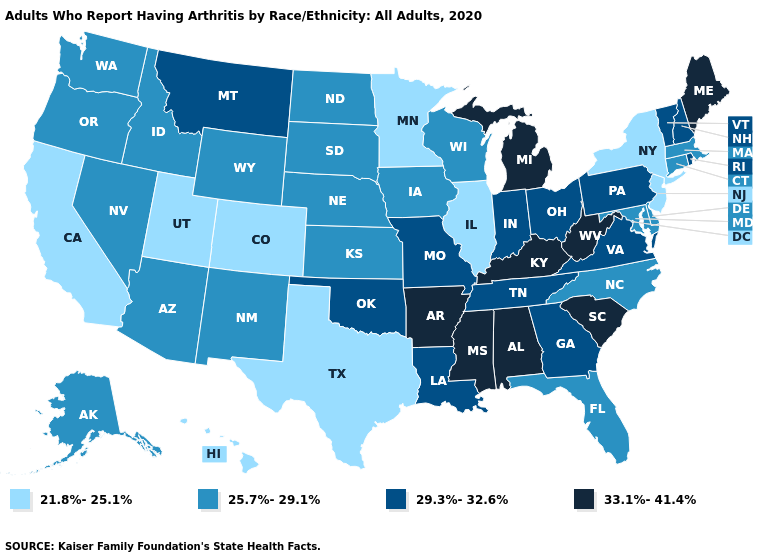Name the states that have a value in the range 33.1%-41.4%?
Concise answer only. Alabama, Arkansas, Kentucky, Maine, Michigan, Mississippi, South Carolina, West Virginia. Which states have the highest value in the USA?
Give a very brief answer. Alabama, Arkansas, Kentucky, Maine, Michigan, Mississippi, South Carolina, West Virginia. Name the states that have a value in the range 25.7%-29.1%?
Short answer required. Alaska, Arizona, Connecticut, Delaware, Florida, Idaho, Iowa, Kansas, Maryland, Massachusetts, Nebraska, Nevada, New Mexico, North Carolina, North Dakota, Oregon, South Dakota, Washington, Wisconsin, Wyoming. What is the highest value in the West ?
Answer briefly. 29.3%-32.6%. Does North Carolina have a higher value than Pennsylvania?
Concise answer only. No. Name the states that have a value in the range 21.8%-25.1%?
Concise answer only. California, Colorado, Hawaii, Illinois, Minnesota, New Jersey, New York, Texas, Utah. Name the states that have a value in the range 25.7%-29.1%?
Write a very short answer. Alaska, Arizona, Connecticut, Delaware, Florida, Idaho, Iowa, Kansas, Maryland, Massachusetts, Nebraska, Nevada, New Mexico, North Carolina, North Dakota, Oregon, South Dakota, Washington, Wisconsin, Wyoming. What is the value of Kansas?
Keep it brief. 25.7%-29.1%. Does Maine have the lowest value in the USA?
Give a very brief answer. No. Name the states that have a value in the range 29.3%-32.6%?
Concise answer only. Georgia, Indiana, Louisiana, Missouri, Montana, New Hampshire, Ohio, Oklahoma, Pennsylvania, Rhode Island, Tennessee, Vermont, Virginia. How many symbols are there in the legend?
Keep it brief. 4. Does Washington have a higher value than Hawaii?
Keep it brief. Yes. Does Delaware have the same value as Wisconsin?
Write a very short answer. Yes. Does Michigan have the highest value in the MidWest?
Give a very brief answer. Yes. What is the highest value in the USA?
Keep it brief. 33.1%-41.4%. 